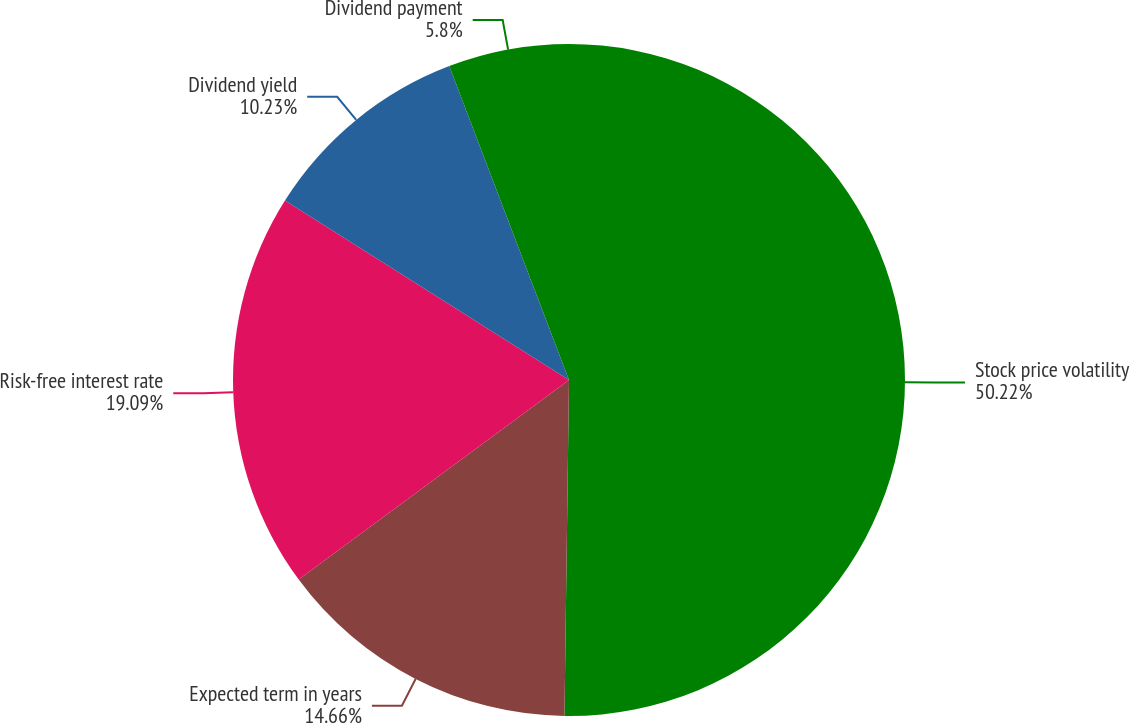<chart> <loc_0><loc_0><loc_500><loc_500><pie_chart><fcel>Stock price volatility<fcel>Expected term in years<fcel>Risk-free interest rate<fcel>Dividend yield<fcel>Dividend payment<nl><fcel>50.21%<fcel>14.66%<fcel>19.09%<fcel>10.23%<fcel>5.8%<nl></chart> 